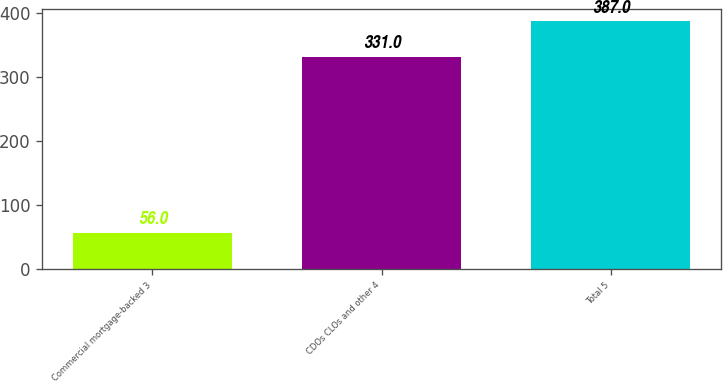Convert chart. <chart><loc_0><loc_0><loc_500><loc_500><bar_chart><fcel>Commercial mortgage-backed 3<fcel>CDOs CLOs and other 4<fcel>Total 5<nl><fcel>56<fcel>331<fcel>387<nl></chart> 